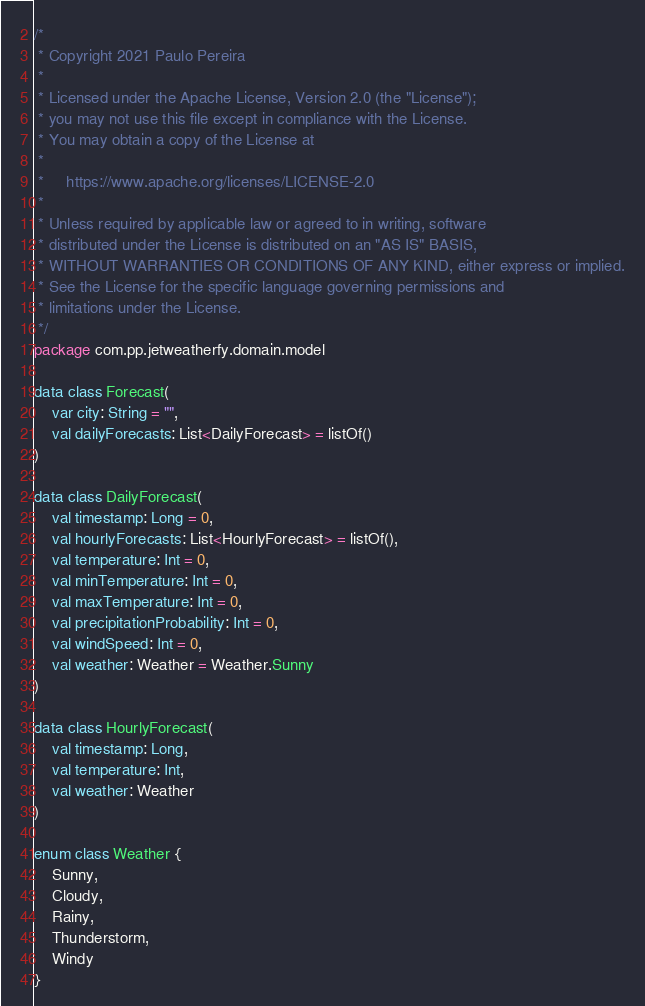Convert code to text. <code><loc_0><loc_0><loc_500><loc_500><_Kotlin_>/*
 * Copyright 2021 Paulo Pereira
 *
 * Licensed under the Apache License, Version 2.0 (the "License");
 * you may not use this file except in compliance with the License.
 * You may obtain a copy of the License at
 *
 *     https://www.apache.org/licenses/LICENSE-2.0
 *
 * Unless required by applicable law or agreed to in writing, software
 * distributed under the License is distributed on an "AS IS" BASIS,
 * WITHOUT WARRANTIES OR CONDITIONS OF ANY KIND, either express or implied.
 * See the License for the specific language governing permissions and
 * limitations under the License.
 */
package com.pp.jetweatherfy.domain.model

data class Forecast(
    var city: String = "",
    val dailyForecasts: List<DailyForecast> = listOf()
)

data class DailyForecast(
    val timestamp: Long = 0,
    val hourlyForecasts: List<HourlyForecast> = listOf(),
    val temperature: Int = 0,
    val minTemperature: Int = 0,
    val maxTemperature: Int = 0,
    val precipitationProbability: Int = 0,
    val windSpeed: Int = 0,
    val weather: Weather = Weather.Sunny
)

data class HourlyForecast(
    val timestamp: Long,
    val temperature: Int,
    val weather: Weather
)

enum class Weather {
    Sunny,
    Cloudy,
    Rainy,
    Thunderstorm,
    Windy
}
</code> 